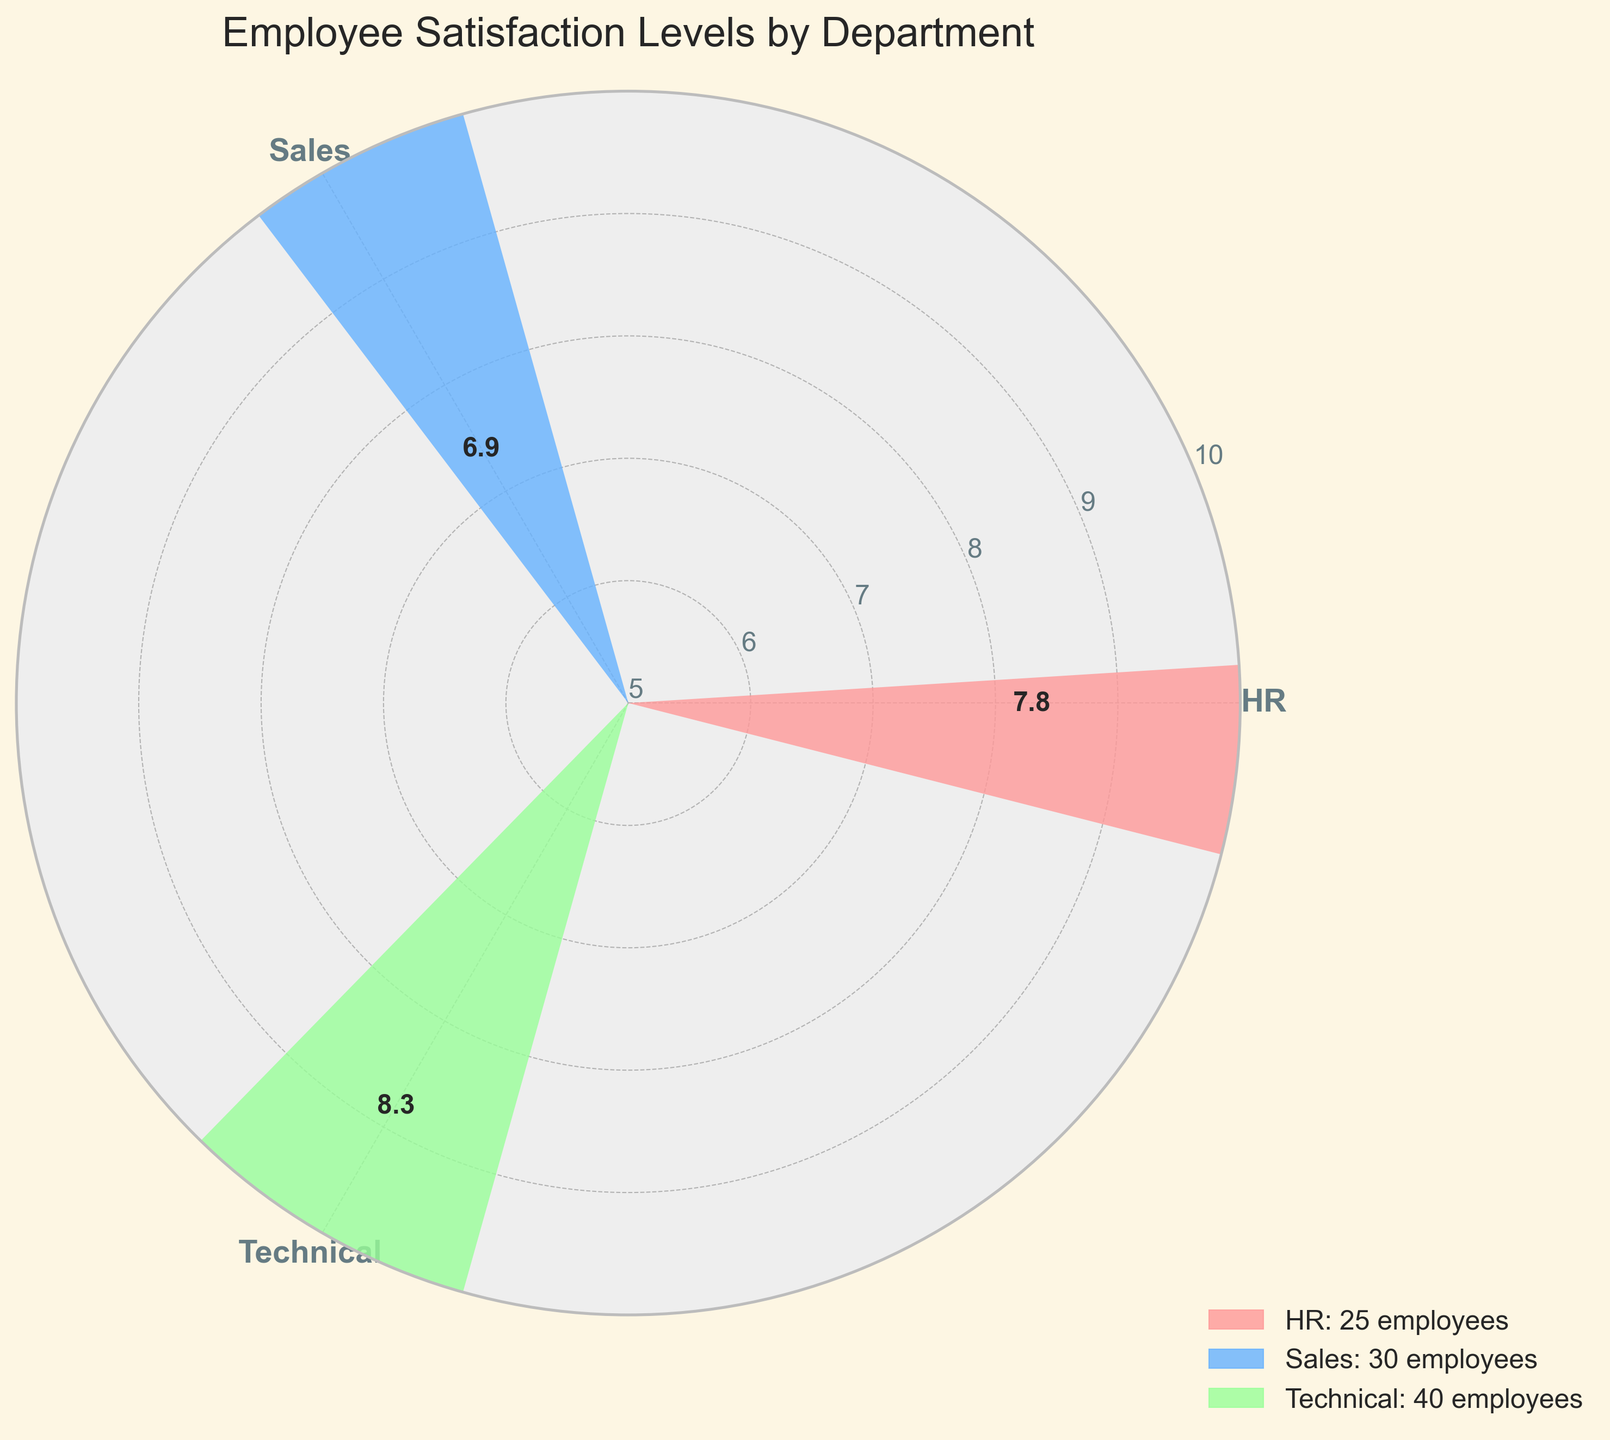what is the title of the chart? The title of the chart is "Employee Satisfaction Levels by Department". This can be seen at the top of the figure.
Answer: Employee Satisfaction Levels by Department What is the average satisfaction level for Sales? The average satisfaction level for Sales is represented as a bar extending outward with the value labeled on it. In the figure, the labeled value for the Sales department is 6.9.
Answer: 6.9 Which department has the highest average satisfaction level? The highest average satisfaction level is indicated by the longest bar. The Technical department has the longest bar with a labeled value of 8.3.
Answer: Technical What is the color used to represent the HR department? Each bar is color-coded, and HR is represented by a specific color. In the figure, HR is shown in a light red/pink color.
Answer: light red/pink How many departments are shown in the chart? The number of departments can be determined by counting the distinct labeled bars in the chart. There are three departments: HR, Sales, and Technical.
Answer: 3 How does the average satisfaction level of the HR department compare to that of Sales? To compare, we look at the lengths and the labeled values of the bars for HR and Sales. The HR department has an average satisfaction level of 7.8, which is higher than the Sales department's average of 6.9.
Answer: HR's average is higher than Sales' What is the range of the average satisfaction levels shown in the chart? The range can be determined by finding the difference between the maximum and minimum average satisfaction levels. The maximum is 8.3 (Technical) and the minimum is 6.9 (Sales). The range is 8.3 - 6.9 = 1.4.
Answer: 1.4 How are the employee counts represented in the chart? The employee counts are represented by the width of the bars. The widths are proportional to the normalized employee counts: HR with 25 employees, Sales with 30 employees, and Technical with 40 employees.
Answer: By the width of the bars What is the normalized width of the bar for the department with the most employees? The department with the most employees is Technical with 40 employees. The normalized width is calculated as (40 / 40) * 0.5 = 0.5.
Answer: 0.5 Which department has the smallest employee count? The smallest employee count corresponds to the department with the narrowest bar. HR has the narrowest bar and the employee count is 25.
Answer: HR 